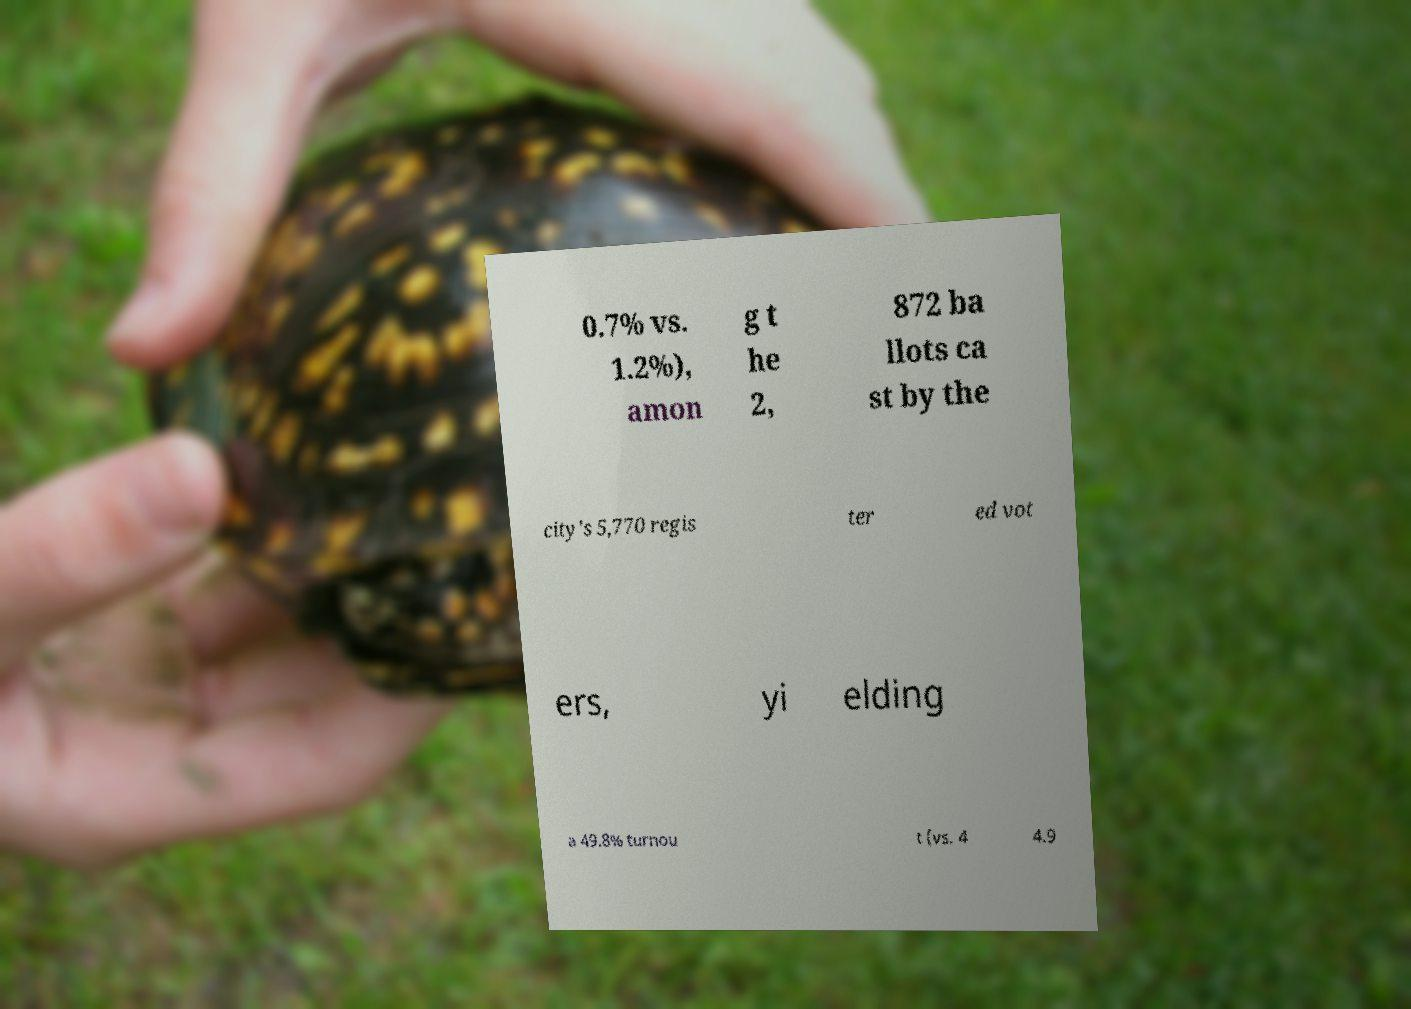What messages or text are displayed in this image? I need them in a readable, typed format. 0.7% vs. 1.2%), amon g t he 2, 872 ba llots ca st by the city's 5,770 regis ter ed vot ers, yi elding a 49.8% turnou t (vs. 4 4.9 